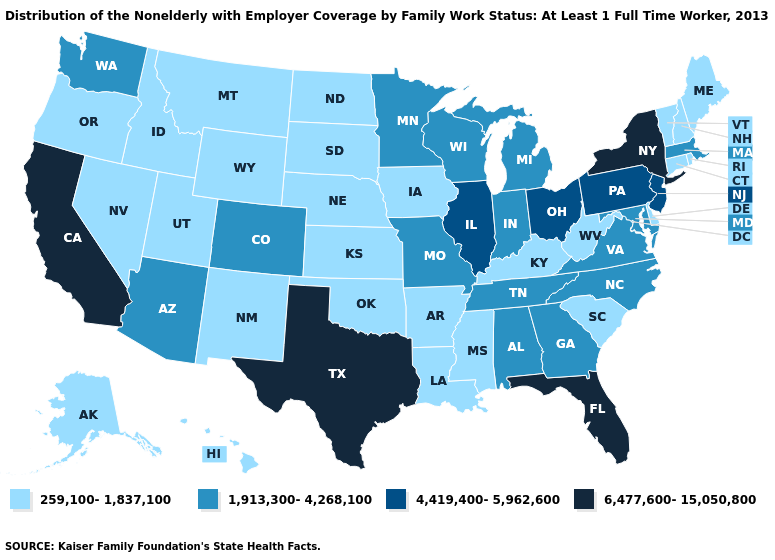Does West Virginia have the same value as Ohio?
Write a very short answer. No. What is the lowest value in states that border Maryland?
Keep it brief. 259,100-1,837,100. What is the value of Ohio?
Be succinct. 4,419,400-5,962,600. Among the states that border South Dakota , does Wyoming have the highest value?
Short answer required. No. Name the states that have a value in the range 1,913,300-4,268,100?
Short answer required. Alabama, Arizona, Colorado, Georgia, Indiana, Maryland, Massachusetts, Michigan, Minnesota, Missouri, North Carolina, Tennessee, Virginia, Washington, Wisconsin. What is the value of Indiana?
Short answer required. 1,913,300-4,268,100. Does New Hampshire have a lower value than Washington?
Keep it brief. Yes. What is the value of Michigan?
Quick response, please. 1,913,300-4,268,100. Name the states that have a value in the range 4,419,400-5,962,600?
Answer briefly. Illinois, New Jersey, Ohio, Pennsylvania. Name the states that have a value in the range 6,477,600-15,050,800?
Short answer required. California, Florida, New York, Texas. Does Iowa have the lowest value in the USA?
Be succinct. Yes. What is the value of Oregon?
Give a very brief answer. 259,100-1,837,100. Among the states that border New Jersey , does Delaware have the lowest value?
Concise answer only. Yes. Is the legend a continuous bar?
Be succinct. No. Name the states that have a value in the range 259,100-1,837,100?
Short answer required. Alaska, Arkansas, Connecticut, Delaware, Hawaii, Idaho, Iowa, Kansas, Kentucky, Louisiana, Maine, Mississippi, Montana, Nebraska, Nevada, New Hampshire, New Mexico, North Dakota, Oklahoma, Oregon, Rhode Island, South Carolina, South Dakota, Utah, Vermont, West Virginia, Wyoming. 